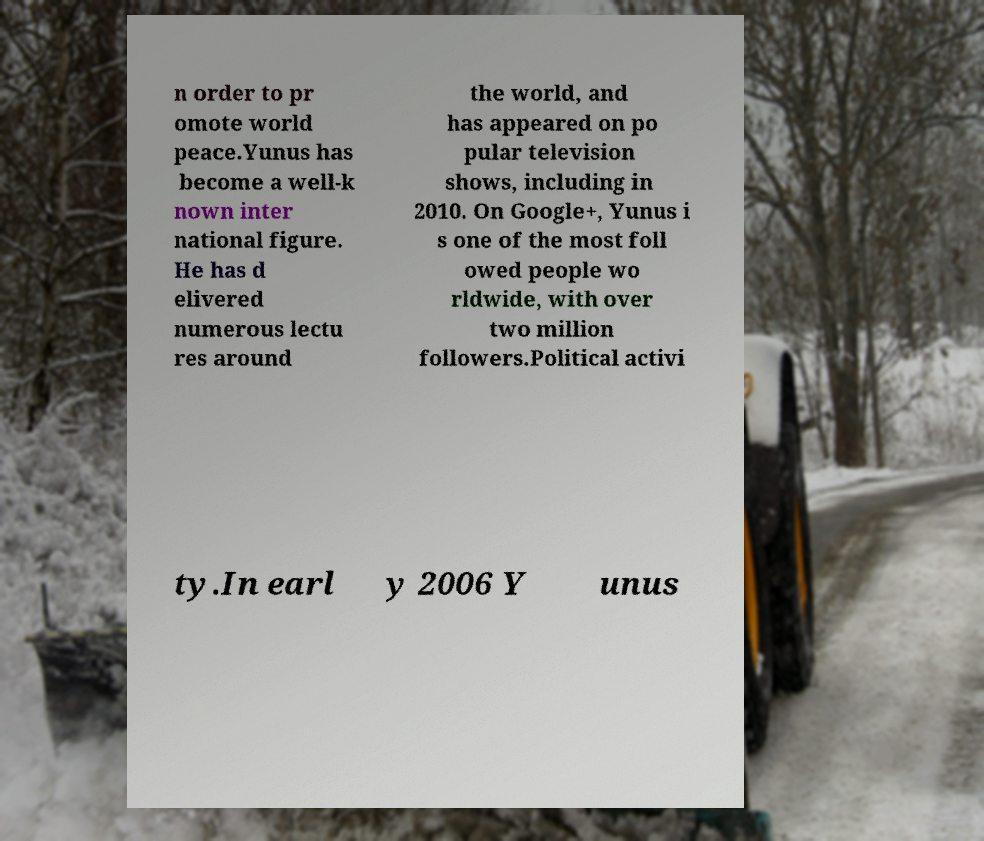Could you extract and type out the text from this image? n order to pr omote world peace.Yunus has become a well-k nown inter national figure. He has d elivered numerous lectu res around the world, and has appeared on po pular television shows, including in 2010. On Google+, Yunus i s one of the most foll owed people wo rldwide, with over two million followers.Political activi ty.In earl y 2006 Y unus 